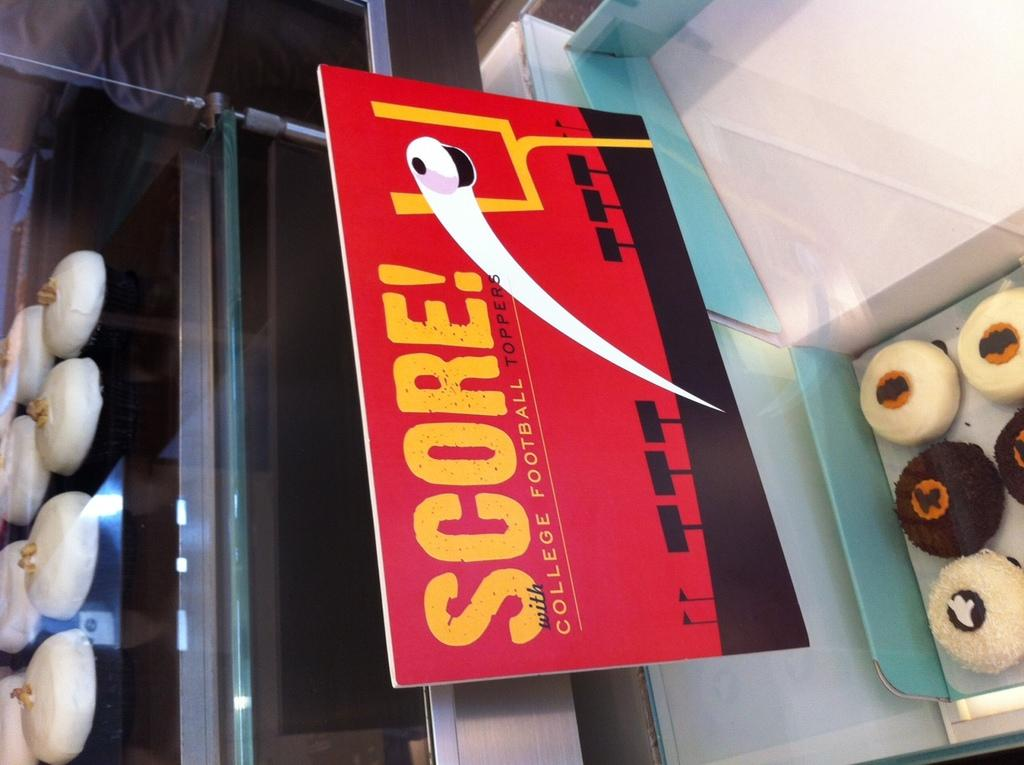What is inside the box in the image? There are deserts in a box in the image. What else can be seen in the image besides the box? There is a board and a person in the background of the image. Are there any other deserts visible in the image? Yes, there are other deserts on a stand in the image. What type of lace can be seen on the sofa in the image? There is no sofa or lace present in the image. How does the person in the background plan to swim in the image? There is no swimming or reference to water in the image. 